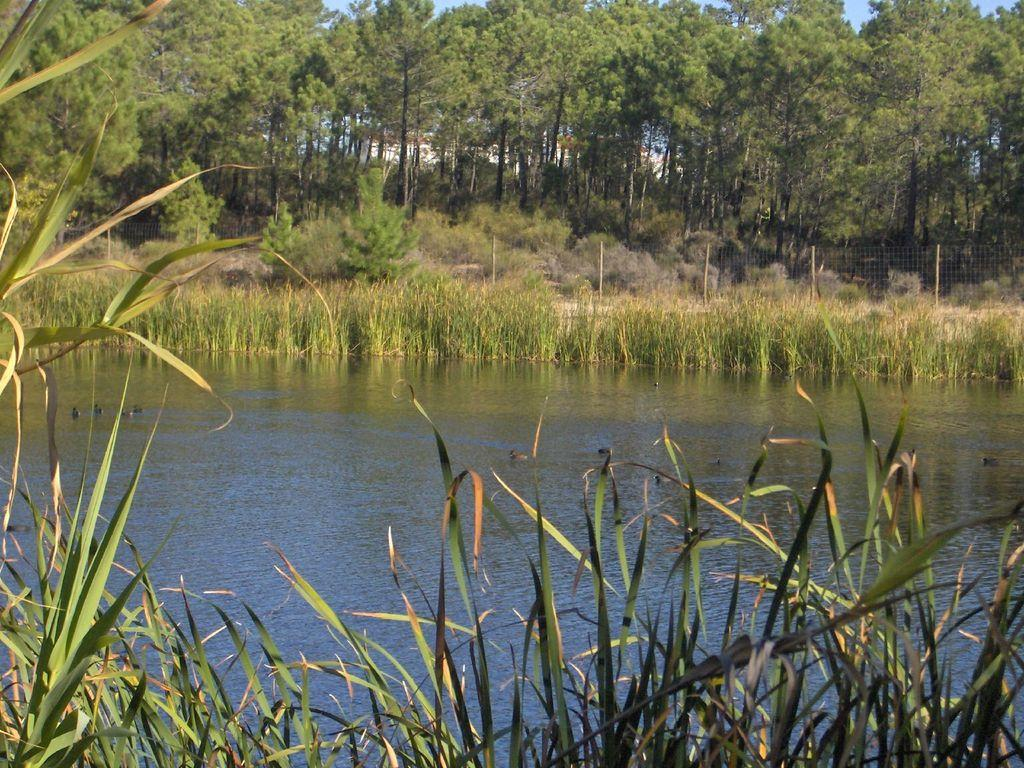What is the main feature in the center of the image? There is water in the center of the image. What can be seen at the top side of the image? There are trees and grassland at the top side of the image. What type of vegetation is present at the bottom side of the image? There is grassland at the bottom side of the image. What flavor of mitten is being worn by the mice in the image? There are no mice or mittens present in the image, so it is not possible to determine the flavor of any mitten. 